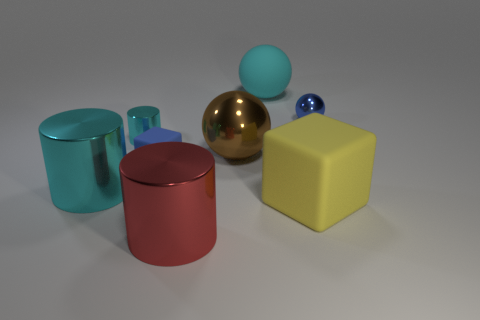There is a large rubber thing on the right side of the cyan object right of the large thing that is in front of the large yellow object; what color is it? The rubber object you're referring to is actually not distinguishable in terms of material in the image and appears to be smaller in size, not large. However, assuming you mean the sphere beside the cyan cylinder which is to the right of the brass-colored sphere, it is blue in color. 